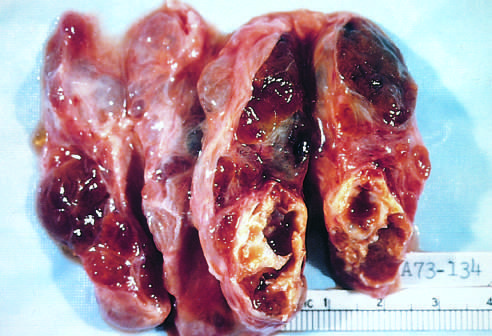what does the coarsely nodular gland contain?
Answer the question using a single word or phrase. Areas of fibrosis and cystic change 